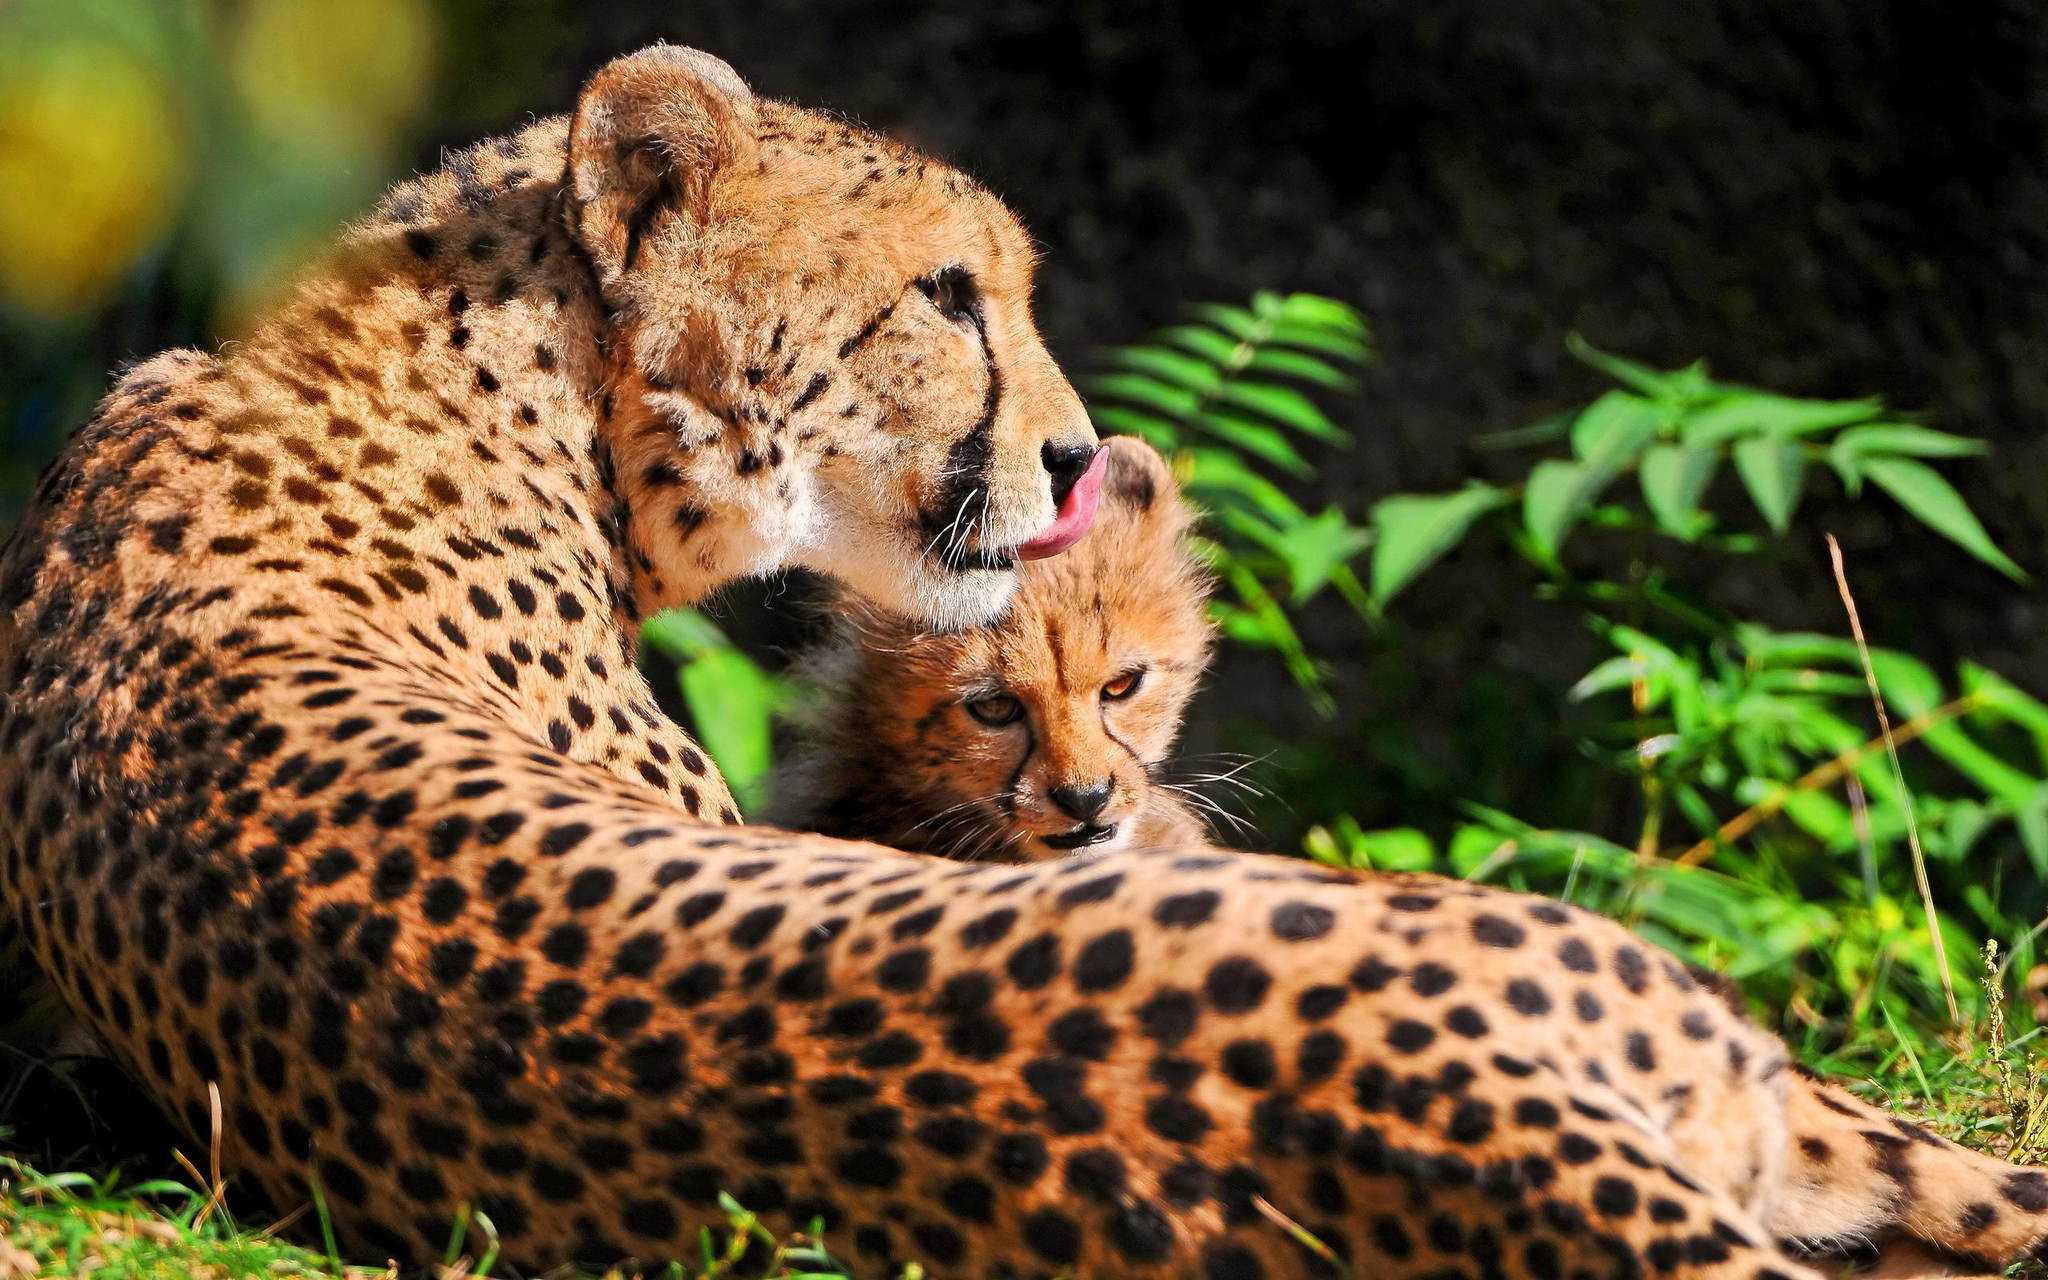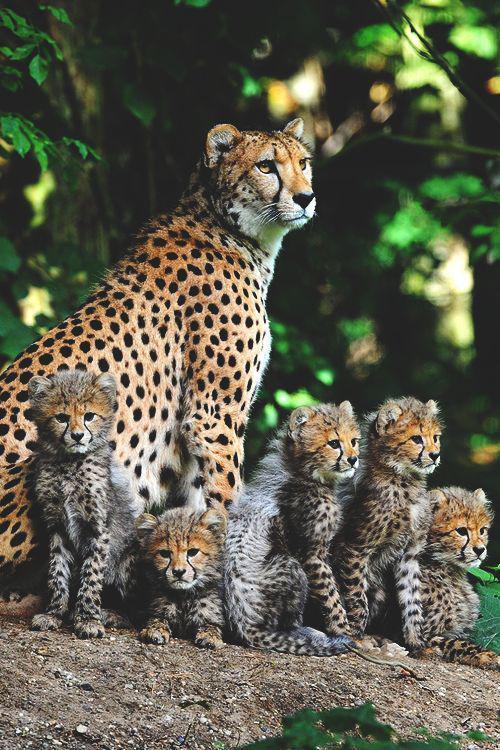The first image is the image on the left, the second image is the image on the right. Given the left and right images, does the statement "An image contains only a non-standing adult wild cat and one kitten, posed with their faces close together." hold true? Answer yes or no. Yes. The first image is the image on the left, the second image is the image on the right. Examine the images to the left and right. Is the description "There are exactly eight cheetahs." accurate? Answer yes or no. Yes. 